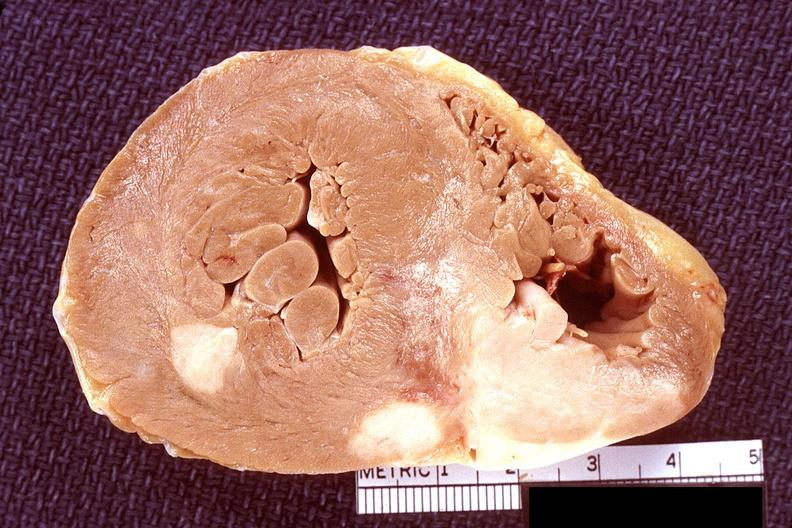does this image show heart, lymphoma?
Answer the question using a single word or phrase. Yes 